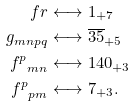Convert formula to latex. <formula><loc_0><loc_0><loc_500><loc_500>\ f r & \longleftrightarrow { 1 _ { + 7 } } \\ g _ { m n p q } & \longleftrightarrow { \overline { 3 5 } _ { + 5 } } \\ { f ^ { p } } _ { m n } & \longleftrightarrow { 1 4 0 _ { + 3 } } \\ { f ^ { p } } _ { p m } & \longleftrightarrow { 7 _ { + 3 } } .</formula> 